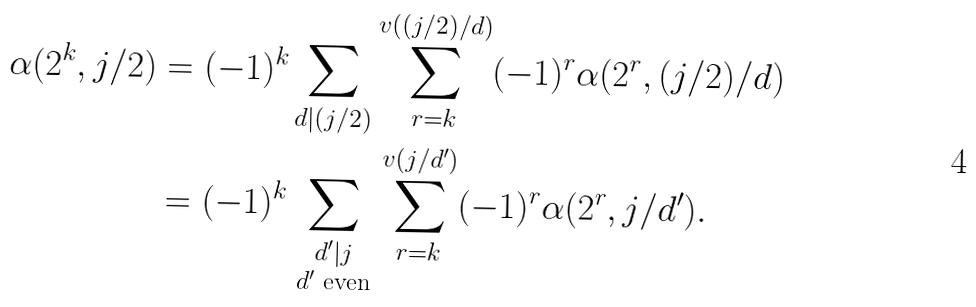<formula> <loc_0><loc_0><loc_500><loc_500>\alpha ( 2 ^ { k } , j / 2 ) & = ( - 1 ) ^ { k } \sum _ { d | ( j / 2 ) } \sum _ { r = k } ^ { v ( ( j / 2 ) / d ) } ( - 1 ) ^ { r } \alpha ( 2 ^ { r } , ( j / 2 ) / d ) \\ & = ( - 1 ) ^ { k } \sum _ { \begin{smallmatrix} d ^ { \prime } | j \\ \text {$d^{\prime}$ even} \end{smallmatrix} } \sum _ { r = k } ^ { v ( j / d ^ { \prime } ) } ( - 1 ) ^ { r } \alpha ( 2 ^ { r } , j / d ^ { \prime } ) .</formula> 